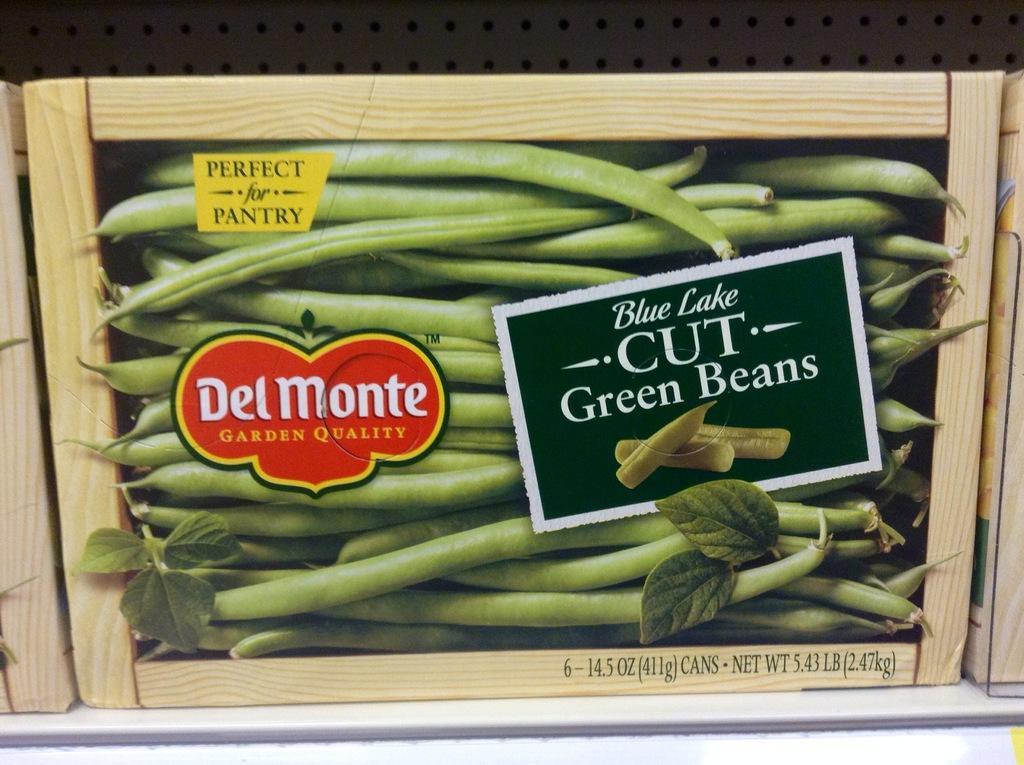Could you give a brief overview of what you see in this image? In this image, in the middle, we can see a wood frame, in the wood frame, we can see some vegetables and some text written on it. On the right side and left side, we can see wood frames. In the background, we can see a wall. At the bottom, we can see white color. 